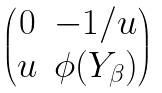Convert formula to latex. <formula><loc_0><loc_0><loc_500><loc_500>\begin{pmatrix} 0 & - 1 / u \\ u & \phi ( Y _ { \beta } ) \end{pmatrix}</formula> 